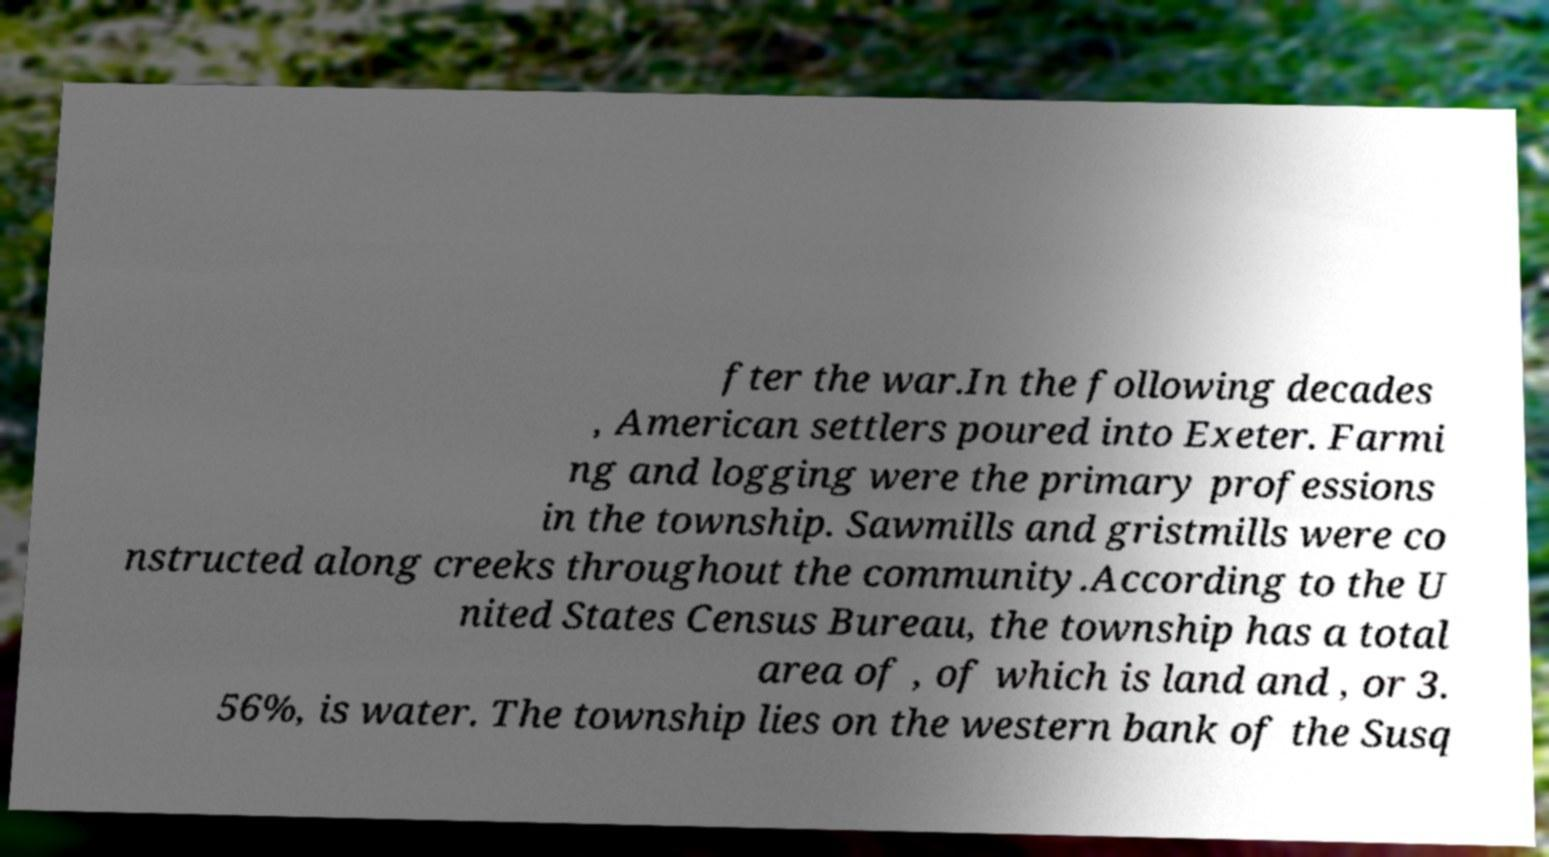Can you read and provide the text displayed in the image?This photo seems to have some interesting text. Can you extract and type it out for me? fter the war.In the following decades , American settlers poured into Exeter. Farmi ng and logging were the primary professions in the township. Sawmills and gristmills were co nstructed along creeks throughout the community.According to the U nited States Census Bureau, the township has a total area of , of which is land and , or 3. 56%, is water. The township lies on the western bank of the Susq 